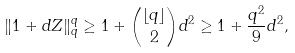Convert formula to latex. <formula><loc_0><loc_0><loc_500><loc_500>\| 1 + d Z \| _ { q } ^ { q } \geq 1 + \binom { \lfloor q \rfloor } { 2 } d ^ { 2 } \geq 1 + \frac { q ^ { 2 } } { 9 } d ^ { 2 } ,</formula> 